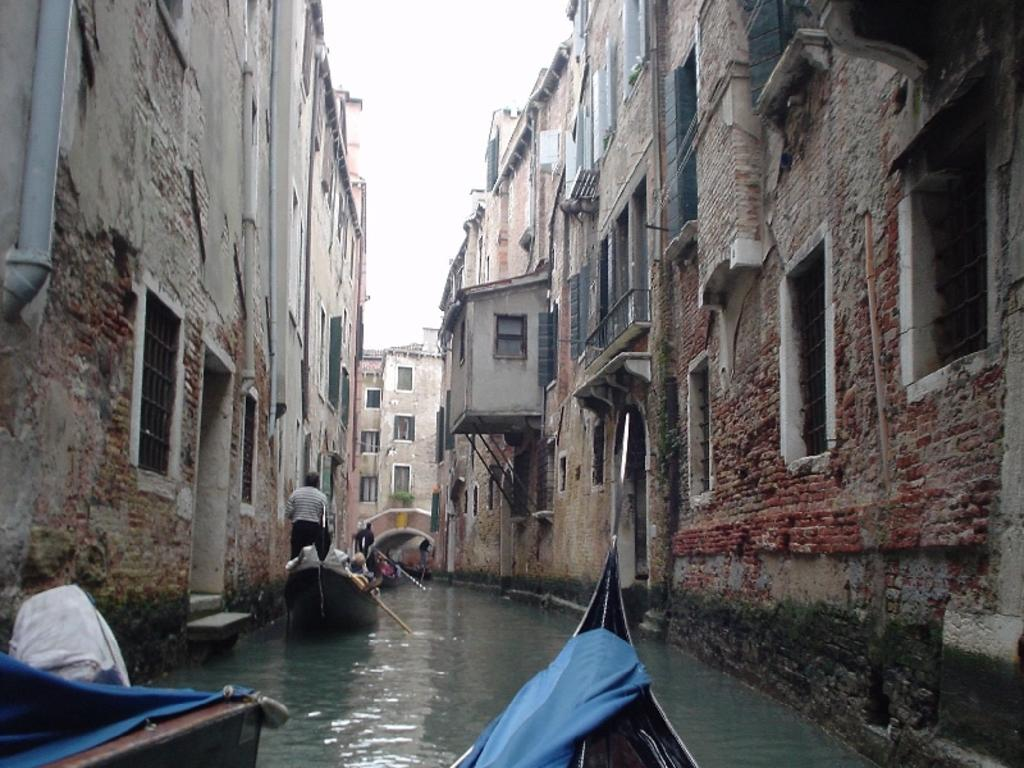What is present at the bottom of the image? There is water in the bottom of the picture. What is floating on the water in the image? There are boats floating on the water. What can be seen in the distance in the image? There are buildings in the background of the image. What is visible above the buildings in the image? The sky is visible in the background of the image. How does the glass reflect the sunlight in the image? There is no glass present in the image; it only features water, boats, buildings, and the sky. 